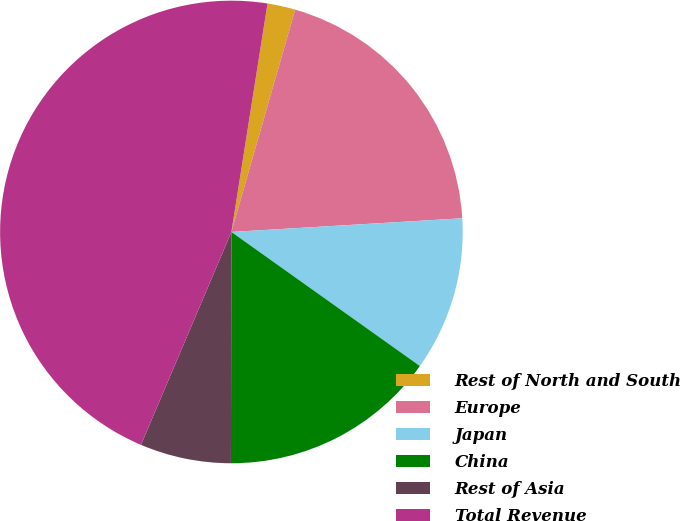Convert chart to OTSL. <chart><loc_0><loc_0><loc_500><loc_500><pie_chart><fcel>Rest of North and South<fcel>Europe<fcel>Japan<fcel>China<fcel>Rest of Asia<fcel>Total Revenue<nl><fcel>1.95%<fcel>19.61%<fcel>10.78%<fcel>15.19%<fcel>6.36%<fcel>46.1%<nl></chart> 